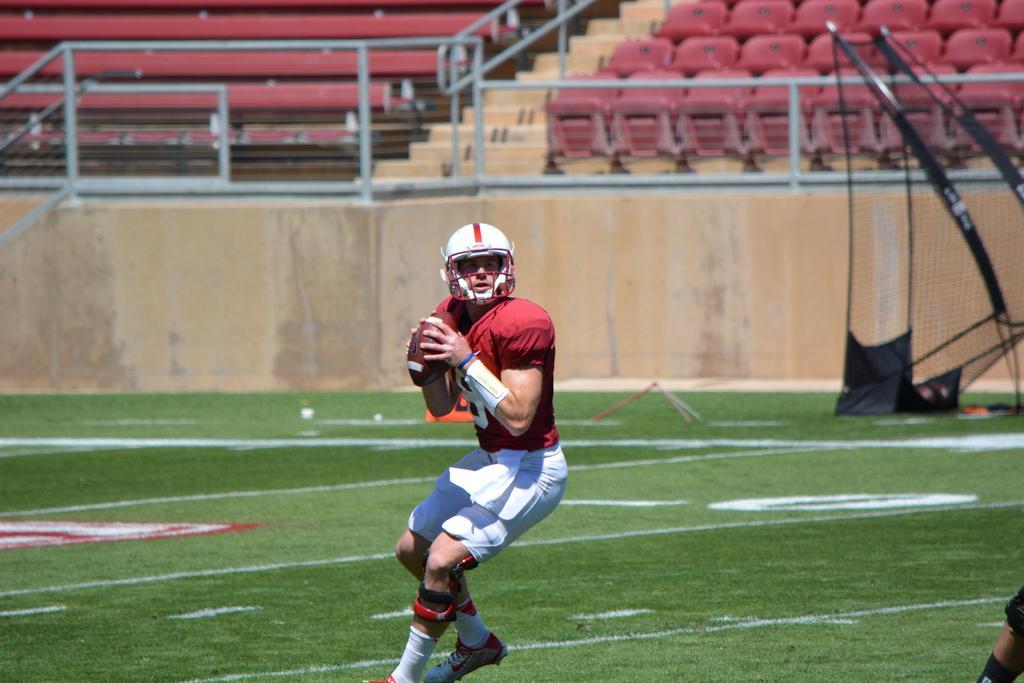Please provide a concise description of this image. In this picture we can see a person wearing a helmet and holding a rugby ball in his hands. We can see the hand of a person in the bottom right. Some grass is visible on the ground. We can see a mesh on the right side. There is a compound wall visible from left to right. There are a few rods. We can see a few chairs and benches in the background. 